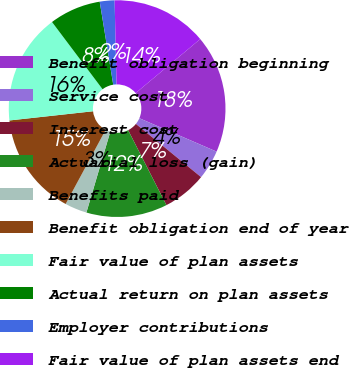Convert chart to OTSL. <chart><loc_0><loc_0><loc_500><loc_500><pie_chart><fcel>Benefit obligation beginning<fcel>Service cost<fcel>Interest cost<fcel>Actuarial loss (gain)<fcel>Benefits paid<fcel>Benefit obligation end of year<fcel>Fair value of plan assets<fcel>Actual return on plan assets<fcel>Employer contributions<fcel>Fair value of plan assets end<nl><fcel>17.58%<fcel>4.4%<fcel>6.59%<fcel>12.09%<fcel>3.3%<fcel>15.38%<fcel>16.48%<fcel>7.69%<fcel>2.2%<fcel>14.28%<nl></chart> 